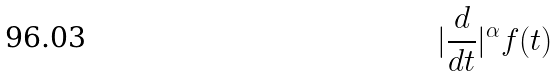<formula> <loc_0><loc_0><loc_500><loc_500>| \frac { d } { d t } | ^ { \alpha } f ( t )</formula> 